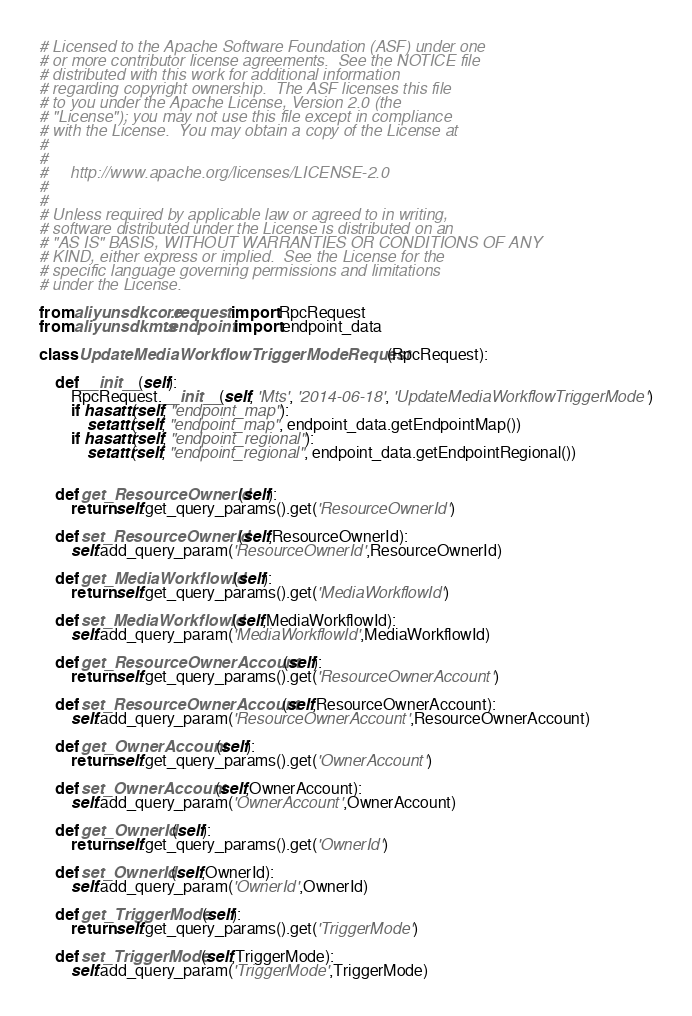<code> <loc_0><loc_0><loc_500><loc_500><_Python_># Licensed to the Apache Software Foundation (ASF) under one
# or more contributor license agreements.  See the NOTICE file
# distributed with this work for additional information
# regarding copyright ownership.  The ASF licenses this file
# to you under the Apache License, Version 2.0 (the
# "License"); you may not use this file except in compliance
# with the License.  You may obtain a copy of the License at
#
#
#     http://www.apache.org/licenses/LICENSE-2.0
#
#
# Unless required by applicable law or agreed to in writing,
# software distributed under the License is distributed on an
# "AS IS" BASIS, WITHOUT WARRANTIES OR CONDITIONS OF ANY
# KIND, either express or implied.  See the License for the
# specific language governing permissions and limitations
# under the License.

from aliyunsdkcore.request import RpcRequest
from aliyunsdkmts.endpoint import endpoint_data

class UpdateMediaWorkflowTriggerModeRequest(RpcRequest):

	def __init__(self):
		RpcRequest.__init__(self, 'Mts', '2014-06-18', 'UpdateMediaWorkflowTriggerMode')
		if hasattr(self, "endpoint_map"):
			setattr(self, "endpoint_map", endpoint_data.getEndpointMap())
		if hasattr(self, "endpoint_regional"):
			setattr(self, "endpoint_regional", endpoint_data.getEndpointRegional())


	def get_ResourceOwnerId(self):
		return self.get_query_params().get('ResourceOwnerId')

	def set_ResourceOwnerId(self,ResourceOwnerId):
		self.add_query_param('ResourceOwnerId',ResourceOwnerId)

	def get_MediaWorkflowId(self):
		return self.get_query_params().get('MediaWorkflowId')

	def set_MediaWorkflowId(self,MediaWorkflowId):
		self.add_query_param('MediaWorkflowId',MediaWorkflowId)

	def get_ResourceOwnerAccount(self):
		return self.get_query_params().get('ResourceOwnerAccount')

	def set_ResourceOwnerAccount(self,ResourceOwnerAccount):
		self.add_query_param('ResourceOwnerAccount',ResourceOwnerAccount)

	def get_OwnerAccount(self):
		return self.get_query_params().get('OwnerAccount')

	def set_OwnerAccount(self,OwnerAccount):
		self.add_query_param('OwnerAccount',OwnerAccount)

	def get_OwnerId(self):
		return self.get_query_params().get('OwnerId')

	def set_OwnerId(self,OwnerId):
		self.add_query_param('OwnerId',OwnerId)

	def get_TriggerMode(self):
		return self.get_query_params().get('TriggerMode')

	def set_TriggerMode(self,TriggerMode):
		self.add_query_param('TriggerMode',TriggerMode)</code> 